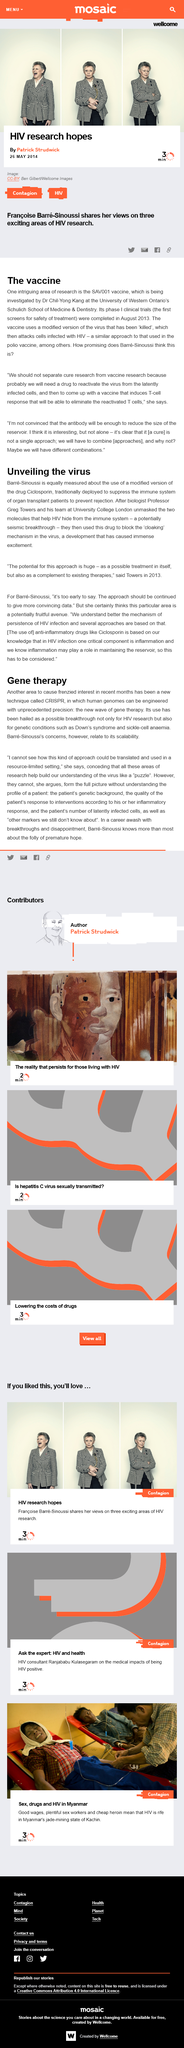Give some essential details in this illustration. The CRISPR technique allows for the engineering of the human genome with unprecedented precision, revolutionizing the field of genome editing. The SAV001 vaccine is currently being investigated by Dr. Chil-Yong Kang at the University of Western Ontario's Schulich School of Medicine and Dentistry. Greg Towers is the lead biologist mentioned in the text. SAV001 vaccine primarily targets T-cells, which play a critical role in immune response and are essential for protecting against infectious diseases. The SAV001 vaccine has been clinically tested and completed phase 1 trials in August 2013. 